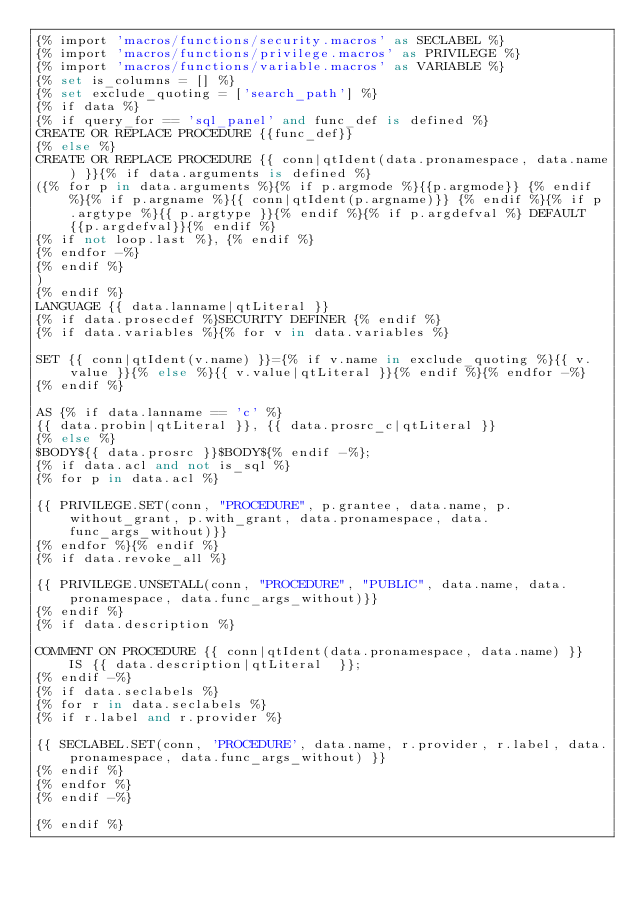<code> <loc_0><loc_0><loc_500><loc_500><_SQL_>{% import 'macros/functions/security.macros' as SECLABEL %}
{% import 'macros/functions/privilege.macros' as PRIVILEGE %}
{% import 'macros/functions/variable.macros' as VARIABLE %}
{% set is_columns = [] %}
{% set exclude_quoting = ['search_path'] %}
{% if data %}
{% if query_for == 'sql_panel' and func_def is defined %}
CREATE OR REPLACE PROCEDURE {{func_def}}
{% else %}
CREATE OR REPLACE PROCEDURE {{ conn|qtIdent(data.pronamespace, data.name) }}{% if data.arguments is defined %}
({% for p in data.arguments %}{% if p.argmode %}{{p.argmode}} {% endif %}{% if p.argname %}{{ conn|qtIdent(p.argname)}} {% endif %}{% if p.argtype %}{{ p.argtype }}{% endif %}{% if p.argdefval %} DEFAULT {{p.argdefval}}{% endif %}
{% if not loop.last %}, {% endif %}
{% endfor -%}
{% endif %}
)
{% endif %}
LANGUAGE {{ data.lanname|qtLiteral }}
{% if data.prosecdef %}SECURITY DEFINER {% endif %}
{% if data.variables %}{% for v in data.variables %}

SET {{ conn|qtIdent(v.name) }}={% if v.name in exclude_quoting %}{{ v.value }}{% else %}{{ v.value|qtLiteral }}{% endif %}{% endfor -%}
{% endif %}

AS {% if data.lanname == 'c' %}
{{ data.probin|qtLiteral }}, {{ data.prosrc_c|qtLiteral }}
{% else %}
$BODY${{ data.prosrc }}$BODY${% endif -%};
{% if data.acl and not is_sql %}
{% for p in data.acl %}

{{ PRIVILEGE.SET(conn, "PROCEDURE", p.grantee, data.name, p.without_grant, p.with_grant, data.pronamespace, data.func_args_without)}}
{% endfor %}{% endif %}
{% if data.revoke_all %}

{{ PRIVILEGE.UNSETALL(conn, "PROCEDURE", "PUBLIC", data.name, data.pronamespace, data.func_args_without)}}
{% endif %}
{% if data.description %}

COMMENT ON PROCEDURE {{ conn|qtIdent(data.pronamespace, data.name) }}
    IS {{ data.description|qtLiteral  }};
{% endif -%}
{% if data.seclabels %}
{% for r in data.seclabels %}
{% if r.label and r.provider %}

{{ SECLABEL.SET(conn, 'PROCEDURE', data.name, r.provider, r.label, data.pronamespace, data.func_args_without) }}
{% endif %}
{% endfor %}
{% endif -%}

{% endif %}
</code> 